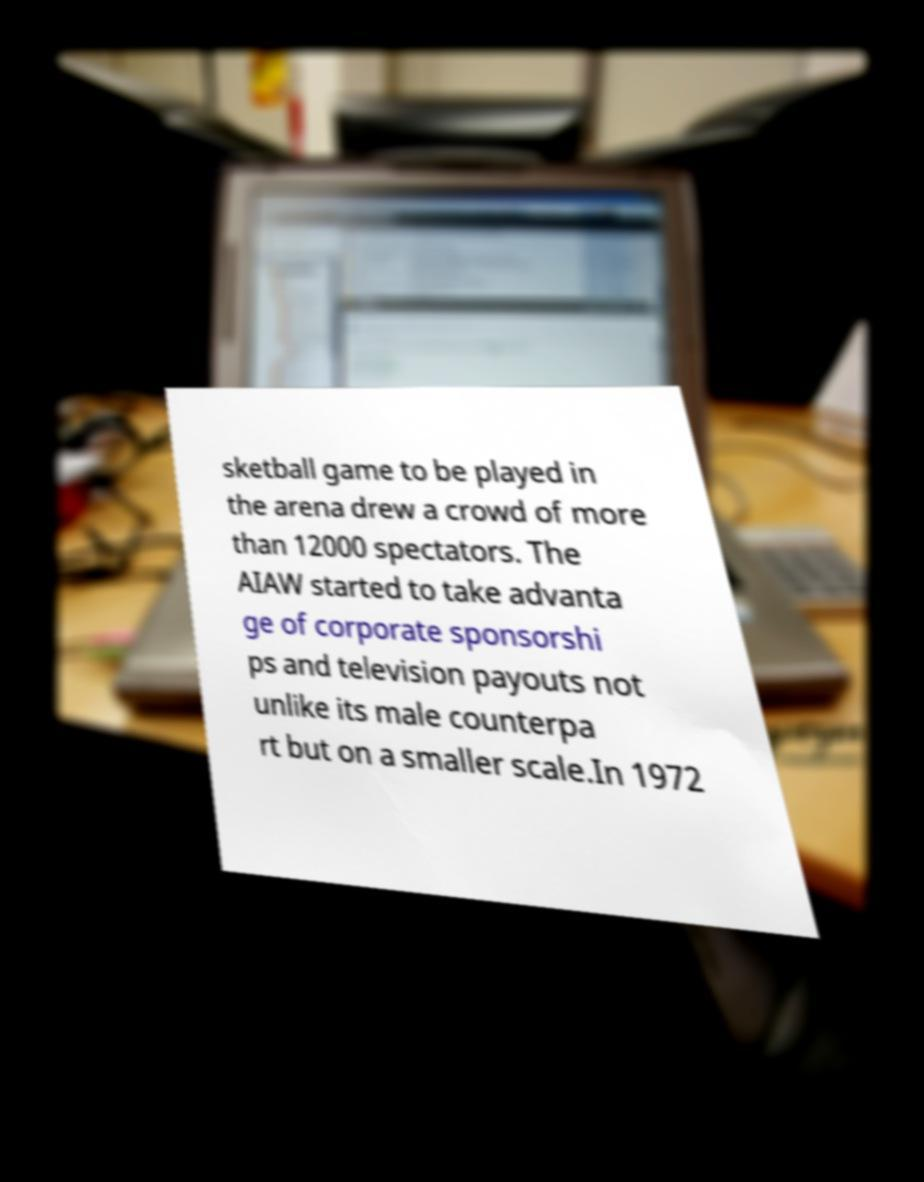Could you assist in decoding the text presented in this image and type it out clearly? sketball game to be played in the arena drew a crowd of more than 12000 spectators. The AIAW started to take advanta ge of corporate sponsorshi ps and television payouts not unlike its male counterpa rt but on a smaller scale.In 1972 